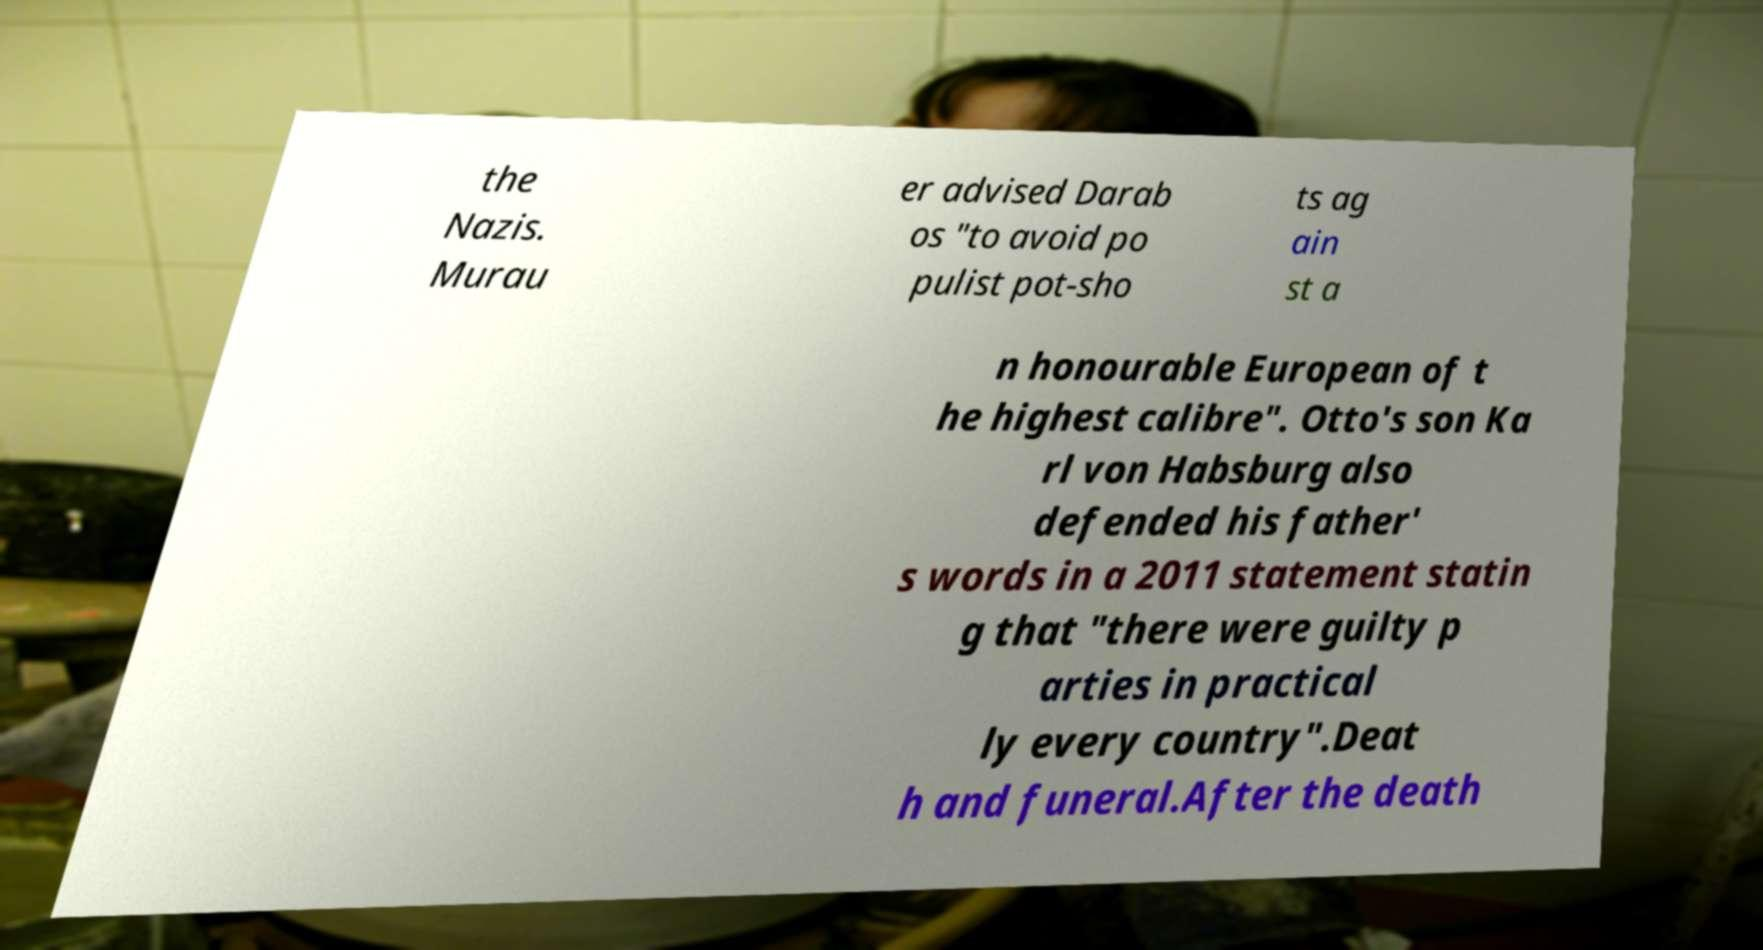There's text embedded in this image that I need extracted. Can you transcribe it verbatim? the Nazis. Murau er advised Darab os "to avoid po pulist pot-sho ts ag ain st a n honourable European of t he highest calibre". Otto's son Ka rl von Habsburg also defended his father' s words in a 2011 statement statin g that "there were guilty p arties in practical ly every country".Deat h and funeral.After the death 